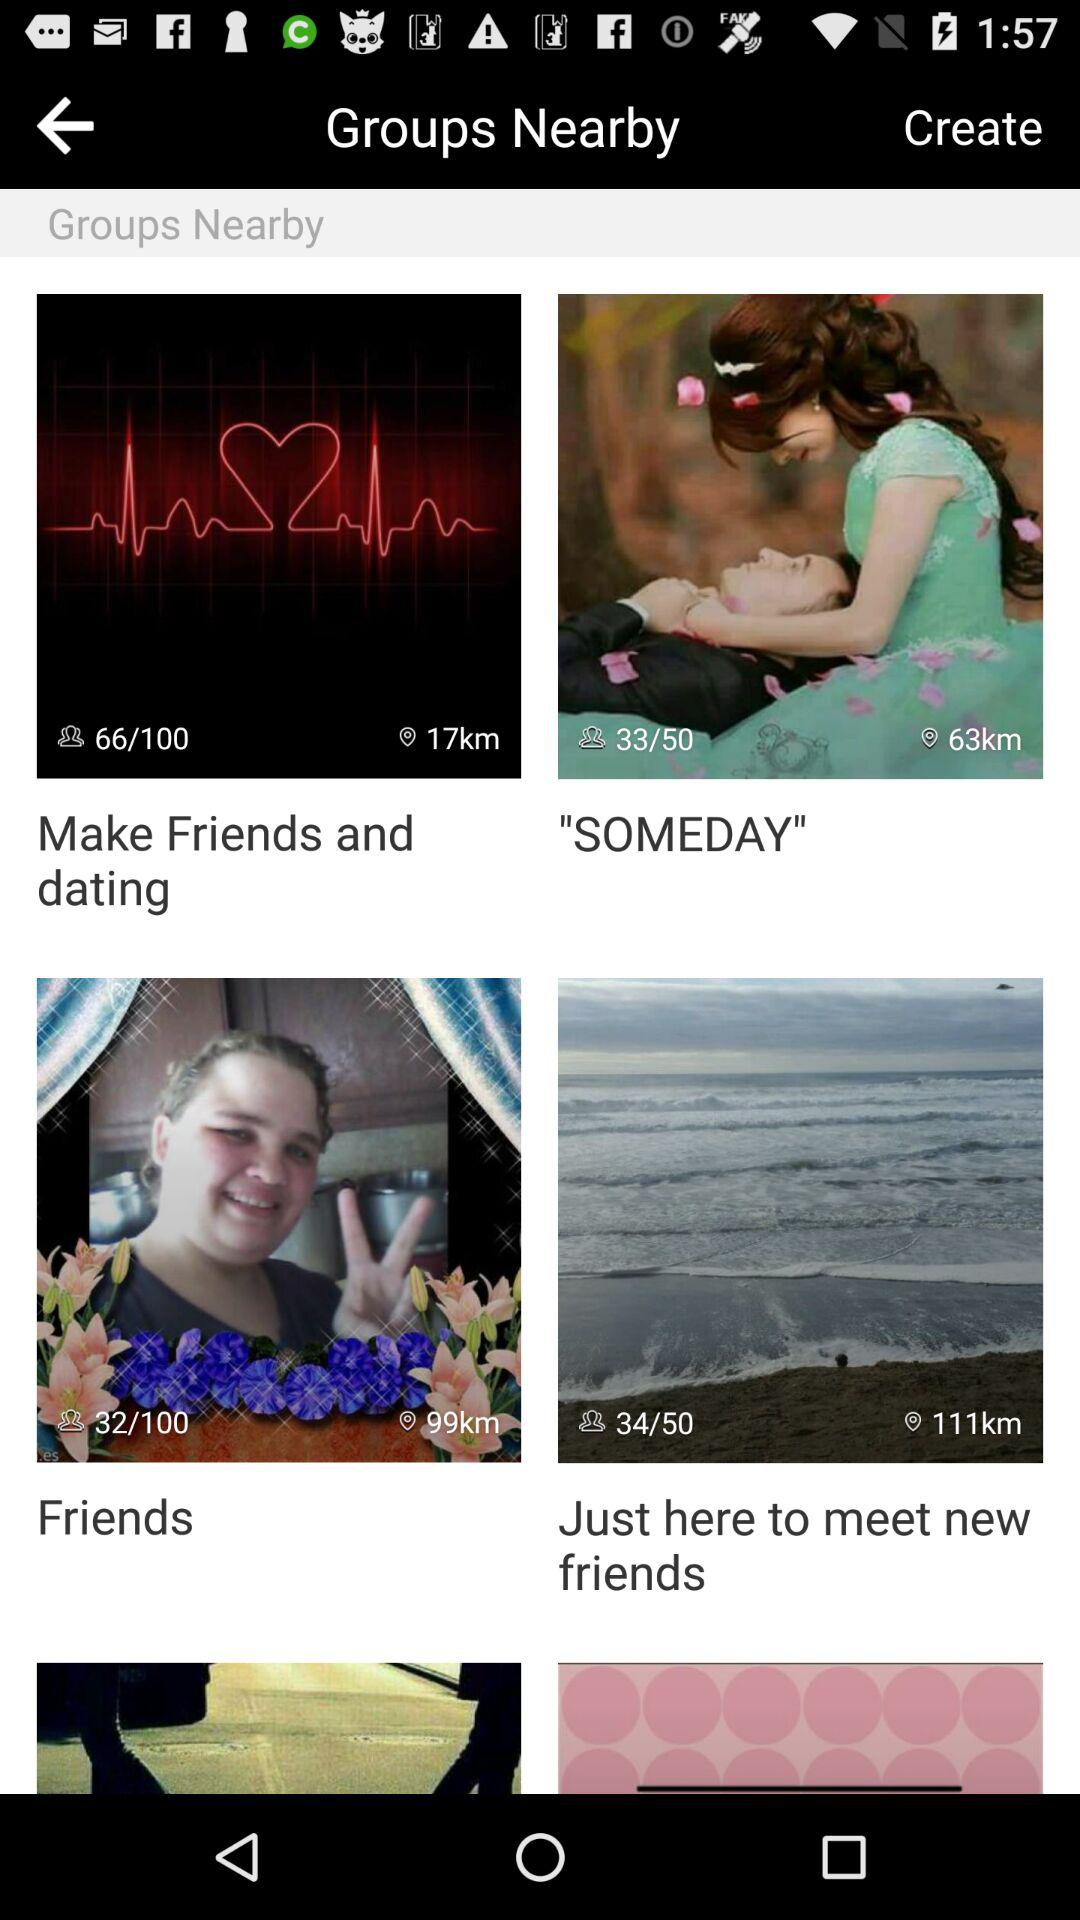What is the distance shown for "SOMEDAY"? The distance is 63 kilometers. 